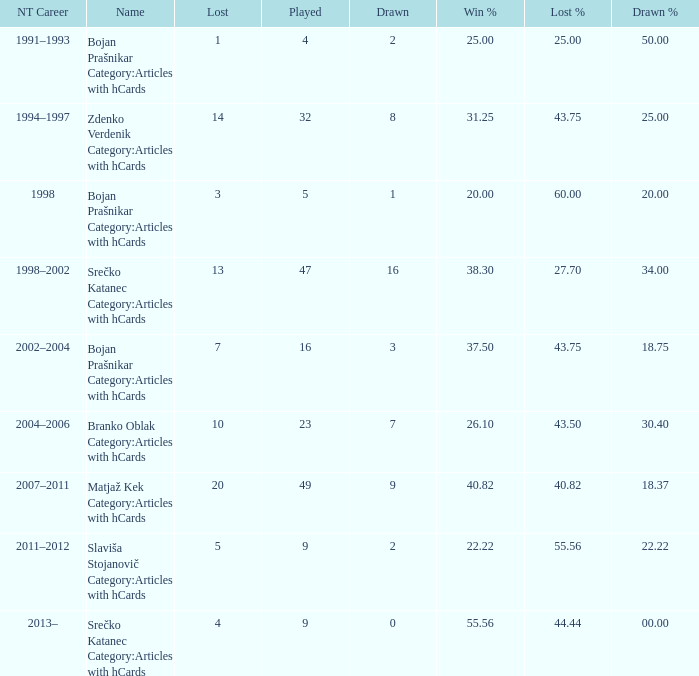How many values for Lost% occur when the value for drawn is 8 and less than 14 lost? 0.0. 